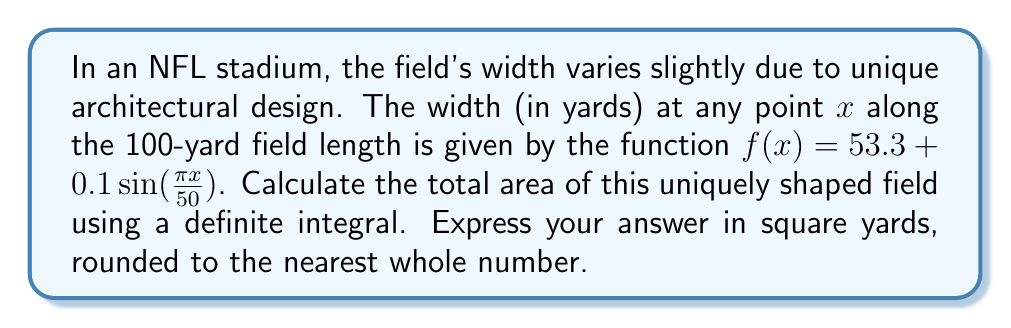Help me with this question. To solve this problem, we need to follow these steps:

1) The area under a curve is given by the definite integral of the function over the specified interval. In this case, we need to integrate $f(x)$ from 0 to 100 yards (the length of the field).

2) Set up the definite integral:

   $$A = \int_0^{100} (53.3 + 0.1\sin(\frac{\pi x}{50})) dx$$

3) Split the integral:

   $$A = \int_0^{100} 53.3 dx + \int_0^{100} 0.1\sin(\frac{\pi x}{50}) dx$$

4) Evaluate the first integral:

   $$\int_0^{100} 53.3 dx = 53.3x \big|_0^{100} = 5330$$

5) For the second integral, use the substitution method:
   Let $u = \frac{\pi x}{50}$, then $du = \frac{\pi}{50} dx$ and $dx = \frac{50}{\pi} du$

   $$\int_0^{100} 0.1\sin(\frac{\pi x}{50}) dx = \frac{5}{\pi} \int_0^{2\pi} \sin(u) du$$

6) Evaluate the second integral:

   $$\frac{5}{\pi} [-\cos(u)] \big|_0^{2\pi} = \frac{5}{\pi} [-\cos(2\pi) + \cos(0)] = 0$$

7) Sum the results:

   $$A = 5330 + 0 = 5330$$ square yards

8) The question asks for the answer rounded to the nearest whole number, but 5330 is already a whole number, so no rounding is necessary.
Answer: 5330 square yards 